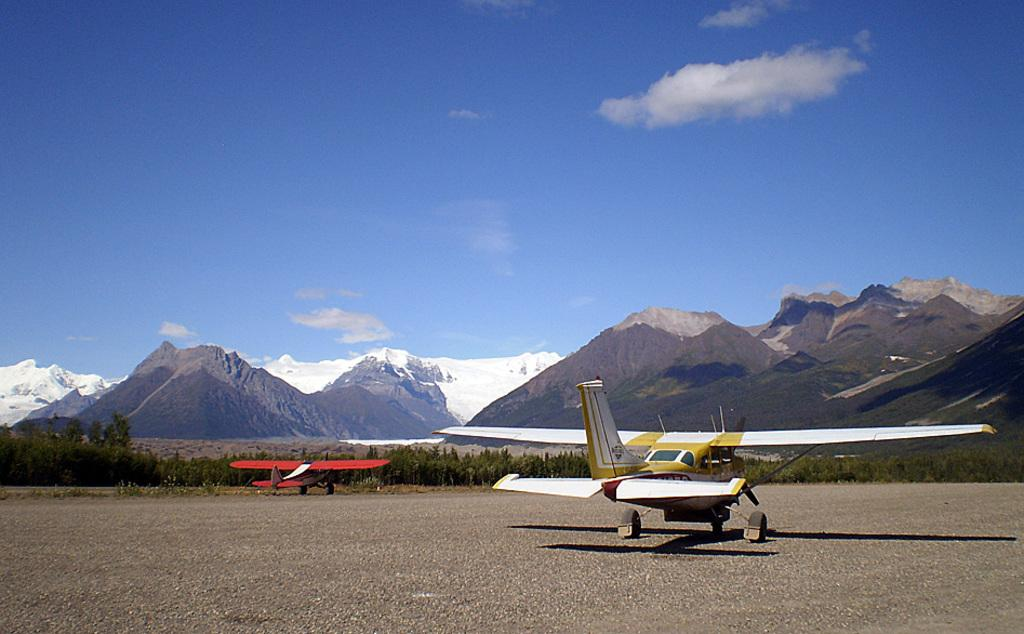What is parked on the road in the image? There are two aircrafts parked on the road in the image. What can be seen behind the aircrafts? There are trees visible behind the aircrafts. What is in the background of the image? There are mountains in the background. How would you describe the sky in the image? The sky is cloudy in the image. How many cakes are being used to decorate the mountains in the image? There are no cakes present in the image, and they are not being used to decorate the mountains. 